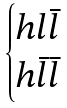Convert formula to latex. <formula><loc_0><loc_0><loc_500><loc_500>\begin{cases} h l \bar { l } \\ h \bar { l } \bar { l } \end{cases}</formula> 